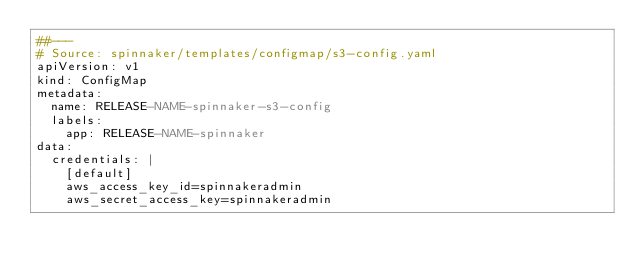<code> <loc_0><loc_0><loc_500><loc_500><_YAML_>##---
# Source: spinnaker/templates/configmap/s3-config.yaml
apiVersion: v1
kind: ConfigMap
metadata:
  name: RELEASE-NAME-spinnaker-s3-config
  labels:
    app: RELEASE-NAME-spinnaker
data:
  credentials: |
    [default]
    aws_access_key_id=spinnakeradmin
    aws_secret_access_key=spinnakeradmin
</code> 